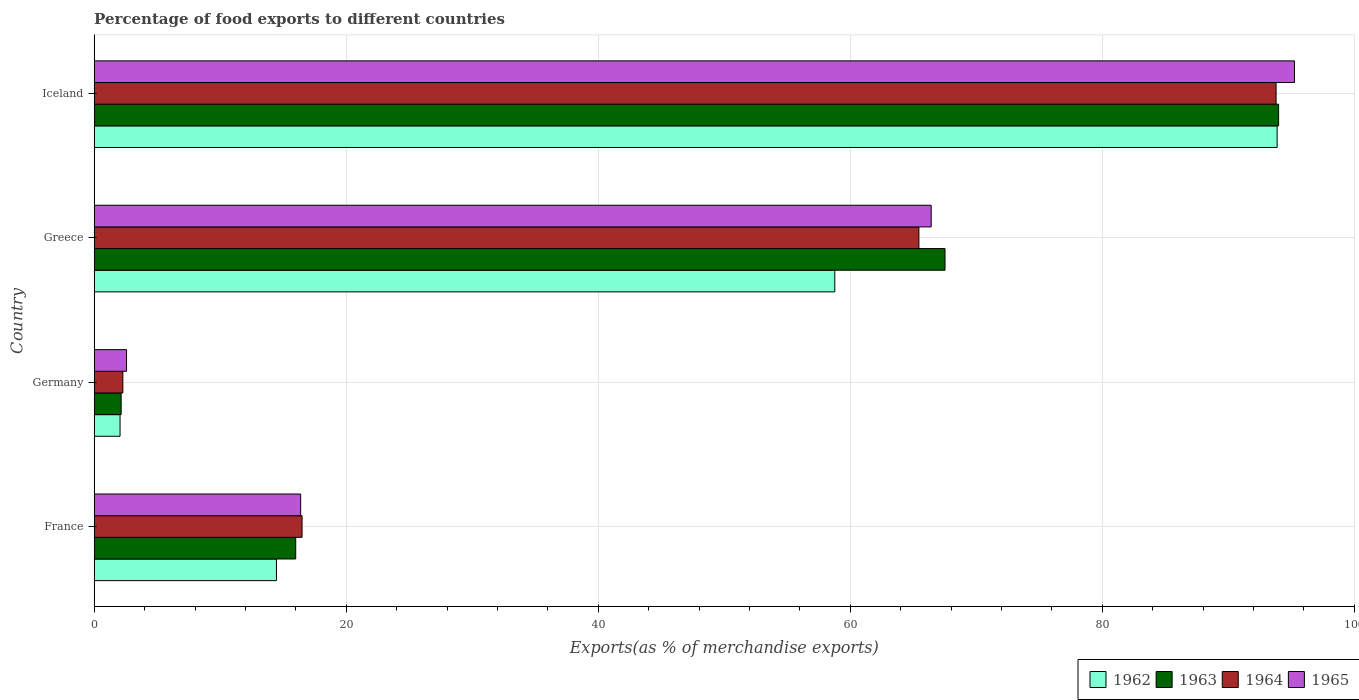How many groups of bars are there?
Your answer should be very brief. 4. Are the number of bars per tick equal to the number of legend labels?
Ensure brevity in your answer.  Yes. Are the number of bars on each tick of the Y-axis equal?
Your response must be concise. Yes. How many bars are there on the 3rd tick from the bottom?
Give a very brief answer. 4. In how many cases, is the number of bars for a given country not equal to the number of legend labels?
Your response must be concise. 0. What is the percentage of exports to different countries in 1963 in Germany?
Your answer should be compact. 2.14. Across all countries, what is the maximum percentage of exports to different countries in 1964?
Offer a terse response. 93.79. Across all countries, what is the minimum percentage of exports to different countries in 1964?
Provide a succinct answer. 2.27. In which country was the percentage of exports to different countries in 1965 maximum?
Make the answer very short. Iceland. What is the total percentage of exports to different countries in 1962 in the graph?
Your answer should be very brief. 169.16. What is the difference between the percentage of exports to different countries in 1962 in Greece and that in Iceland?
Keep it short and to the point. -35.1. What is the difference between the percentage of exports to different countries in 1964 in Greece and the percentage of exports to different countries in 1962 in Germany?
Make the answer very short. 63.39. What is the average percentage of exports to different countries in 1965 per country?
Make the answer very short. 45.16. What is the difference between the percentage of exports to different countries in 1964 and percentage of exports to different countries in 1965 in Iceland?
Provide a short and direct response. -1.46. In how many countries, is the percentage of exports to different countries in 1965 greater than 32 %?
Offer a terse response. 2. What is the ratio of the percentage of exports to different countries in 1962 in France to that in Iceland?
Provide a succinct answer. 0.15. Is the percentage of exports to different countries in 1963 in Germany less than that in Greece?
Keep it short and to the point. Yes. What is the difference between the highest and the second highest percentage of exports to different countries in 1962?
Your answer should be compact. 35.1. What is the difference between the highest and the lowest percentage of exports to different countries in 1964?
Your answer should be compact. 91.52. In how many countries, is the percentage of exports to different countries in 1963 greater than the average percentage of exports to different countries in 1963 taken over all countries?
Ensure brevity in your answer.  2. Is it the case that in every country, the sum of the percentage of exports to different countries in 1963 and percentage of exports to different countries in 1965 is greater than the sum of percentage of exports to different countries in 1962 and percentage of exports to different countries in 1964?
Your answer should be very brief. No. What does the 1st bar from the top in Greece represents?
Offer a very short reply. 1965. What does the 2nd bar from the bottom in France represents?
Give a very brief answer. 1963. Are all the bars in the graph horizontal?
Offer a terse response. Yes. How many countries are there in the graph?
Keep it short and to the point. 4. Does the graph contain grids?
Offer a terse response. Yes. How many legend labels are there?
Provide a short and direct response. 4. What is the title of the graph?
Your answer should be very brief. Percentage of food exports to different countries. What is the label or title of the X-axis?
Provide a short and direct response. Exports(as % of merchandise exports). What is the Exports(as % of merchandise exports) of 1962 in France?
Give a very brief answer. 14.46. What is the Exports(as % of merchandise exports) of 1963 in France?
Keep it short and to the point. 15.99. What is the Exports(as % of merchandise exports) in 1964 in France?
Your response must be concise. 16.5. What is the Exports(as % of merchandise exports) of 1965 in France?
Make the answer very short. 16.38. What is the Exports(as % of merchandise exports) in 1962 in Germany?
Offer a terse response. 2.05. What is the Exports(as % of merchandise exports) of 1963 in Germany?
Make the answer very short. 2.14. What is the Exports(as % of merchandise exports) of 1964 in Germany?
Make the answer very short. 2.27. What is the Exports(as % of merchandise exports) in 1965 in Germany?
Your answer should be compact. 2.57. What is the Exports(as % of merchandise exports) in 1962 in Greece?
Offer a terse response. 58.77. What is the Exports(as % of merchandise exports) in 1963 in Greece?
Give a very brief answer. 67.52. What is the Exports(as % of merchandise exports) of 1964 in Greece?
Your answer should be compact. 65.45. What is the Exports(as % of merchandise exports) in 1965 in Greece?
Your answer should be very brief. 66.42. What is the Exports(as % of merchandise exports) of 1962 in Iceland?
Keep it short and to the point. 93.87. What is the Exports(as % of merchandise exports) of 1963 in Iceland?
Give a very brief answer. 93.99. What is the Exports(as % of merchandise exports) in 1964 in Iceland?
Ensure brevity in your answer.  93.79. What is the Exports(as % of merchandise exports) of 1965 in Iceland?
Keep it short and to the point. 95.25. Across all countries, what is the maximum Exports(as % of merchandise exports) in 1962?
Give a very brief answer. 93.87. Across all countries, what is the maximum Exports(as % of merchandise exports) in 1963?
Ensure brevity in your answer.  93.99. Across all countries, what is the maximum Exports(as % of merchandise exports) in 1964?
Make the answer very short. 93.79. Across all countries, what is the maximum Exports(as % of merchandise exports) of 1965?
Provide a succinct answer. 95.25. Across all countries, what is the minimum Exports(as % of merchandise exports) in 1962?
Your response must be concise. 2.05. Across all countries, what is the minimum Exports(as % of merchandise exports) in 1963?
Offer a terse response. 2.14. Across all countries, what is the minimum Exports(as % of merchandise exports) in 1964?
Offer a very short reply. 2.27. Across all countries, what is the minimum Exports(as % of merchandise exports) of 1965?
Your answer should be very brief. 2.57. What is the total Exports(as % of merchandise exports) of 1962 in the graph?
Ensure brevity in your answer.  169.16. What is the total Exports(as % of merchandise exports) of 1963 in the graph?
Make the answer very short. 179.64. What is the total Exports(as % of merchandise exports) of 1964 in the graph?
Make the answer very short. 178.01. What is the total Exports(as % of merchandise exports) of 1965 in the graph?
Ensure brevity in your answer.  180.62. What is the difference between the Exports(as % of merchandise exports) in 1962 in France and that in Germany?
Your response must be concise. 12.41. What is the difference between the Exports(as % of merchandise exports) in 1963 in France and that in Germany?
Offer a very short reply. 13.85. What is the difference between the Exports(as % of merchandise exports) in 1964 in France and that in Germany?
Offer a very short reply. 14.22. What is the difference between the Exports(as % of merchandise exports) in 1965 in France and that in Germany?
Give a very brief answer. 13.82. What is the difference between the Exports(as % of merchandise exports) in 1962 in France and that in Greece?
Make the answer very short. -44.31. What is the difference between the Exports(as % of merchandise exports) of 1963 in France and that in Greece?
Ensure brevity in your answer.  -51.53. What is the difference between the Exports(as % of merchandise exports) in 1964 in France and that in Greece?
Make the answer very short. -48.95. What is the difference between the Exports(as % of merchandise exports) of 1965 in France and that in Greece?
Ensure brevity in your answer.  -50.04. What is the difference between the Exports(as % of merchandise exports) of 1962 in France and that in Iceland?
Make the answer very short. -79.41. What is the difference between the Exports(as % of merchandise exports) in 1963 in France and that in Iceland?
Ensure brevity in your answer.  -78. What is the difference between the Exports(as % of merchandise exports) in 1964 in France and that in Iceland?
Keep it short and to the point. -77.29. What is the difference between the Exports(as % of merchandise exports) of 1965 in France and that in Iceland?
Offer a very short reply. -78.87. What is the difference between the Exports(as % of merchandise exports) of 1962 in Germany and that in Greece?
Offer a very short reply. -56.72. What is the difference between the Exports(as % of merchandise exports) in 1963 in Germany and that in Greece?
Ensure brevity in your answer.  -65.38. What is the difference between the Exports(as % of merchandise exports) of 1964 in Germany and that in Greece?
Make the answer very short. -63.17. What is the difference between the Exports(as % of merchandise exports) of 1965 in Germany and that in Greece?
Give a very brief answer. -63.85. What is the difference between the Exports(as % of merchandise exports) of 1962 in Germany and that in Iceland?
Provide a short and direct response. -91.82. What is the difference between the Exports(as % of merchandise exports) in 1963 in Germany and that in Iceland?
Your answer should be compact. -91.85. What is the difference between the Exports(as % of merchandise exports) of 1964 in Germany and that in Iceland?
Your response must be concise. -91.52. What is the difference between the Exports(as % of merchandise exports) in 1965 in Germany and that in Iceland?
Your response must be concise. -92.68. What is the difference between the Exports(as % of merchandise exports) of 1962 in Greece and that in Iceland?
Your answer should be compact. -35.1. What is the difference between the Exports(as % of merchandise exports) of 1963 in Greece and that in Iceland?
Offer a terse response. -26.47. What is the difference between the Exports(as % of merchandise exports) of 1964 in Greece and that in Iceland?
Give a very brief answer. -28.35. What is the difference between the Exports(as % of merchandise exports) in 1965 in Greece and that in Iceland?
Your answer should be very brief. -28.83. What is the difference between the Exports(as % of merchandise exports) in 1962 in France and the Exports(as % of merchandise exports) in 1963 in Germany?
Keep it short and to the point. 12.32. What is the difference between the Exports(as % of merchandise exports) of 1962 in France and the Exports(as % of merchandise exports) of 1964 in Germany?
Your answer should be compact. 12.19. What is the difference between the Exports(as % of merchandise exports) of 1962 in France and the Exports(as % of merchandise exports) of 1965 in Germany?
Offer a very short reply. 11.9. What is the difference between the Exports(as % of merchandise exports) of 1963 in France and the Exports(as % of merchandise exports) of 1964 in Germany?
Provide a succinct answer. 13.72. What is the difference between the Exports(as % of merchandise exports) of 1963 in France and the Exports(as % of merchandise exports) of 1965 in Germany?
Provide a succinct answer. 13.42. What is the difference between the Exports(as % of merchandise exports) in 1964 in France and the Exports(as % of merchandise exports) in 1965 in Germany?
Give a very brief answer. 13.93. What is the difference between the Exports(as % of merchandise exports) in 1962 in France and the Exports(as % of merchandise exports) in 1963 in Greece?
Offer a terse response. -53.05. What is the difference between the Exports(as % of merchandise exports) of 1962 in France and the Exports(as % of merchandise exports) of 1964 in Greece?
Offer a terse response. -50.98. What is the difference between the Exports(as % of merchandise exports) in 1962 in France and the Exports(as % of merchandise exports) in 1965 in Greece?
Offer a terse response. -51.96. What is the difference between the Exports(as % of merchandise exports) of 1963 in France and the Exports(as % of merchandise exports) of 1964 in Greece?
Offer a terse response. -49.45. What is the difference between the Exports(as % of merchandise exports) of 1963 in France and the Exports(as % of merchandise exports) of 1965 in Greece?
Keep it short and to the point. -50.43. What is the difference between the Exports(as % of merchandise exports) in 1964 in France and the Exports(as % of merchandise exports) in 1965 in Greece?
Offer a very short reply. -49.93. What is the difference between the Exports(as % of merchandise exports) of 1962 in France and the Exports(as % of merchandise exports) of 1963 in Iceland?
Give a very brief answer. -79.53. What is the difference between the Exports(as % of merchandise exports) in 1962 in France and the Exports(as % of merchandise exports) in 1964 in Iceland?
Your response must be concise. -79.33. What is the difference between the Exports(as % of merchandise exports) of 1962 in France and the Exports(as % of merchandise exports) of 1965 in Iceland?
Offer a very short reply. -80.79. What is the difference between the Exports(as % of merchandise exports) in 1963 in France and the Exports(as % of merchandise exports) in 1964 in Iceland?
Provide a short and direct response. -77.8. What is the difference between the Exports(as % of merchandise exports) of 1963 in France and the Exports(as % of merchandise exports) of 1965 in Iceland?
Ensure brevity in your answer.  -79.26. What is the difference between the Exports(as % of merchandise exports) of 1964 in France and the Exports(as % of merchandise exports) of 1965 in Iceland?
Provide a succinct answer. -78.75. What is the difference between the Exports(as % of merchandise exports) of 1962 in Germany and the Exports(as % of merchandise exports) of 1963 in Greece?
Provide a succinct answer. -65.47. What is the difference between the Exports(as % of merchandise exports) in 1962 in Germany and the Exports(as % of merchandise exports) in 1964 in Greece?
Offer a very short reply. -63.39. What is the difference between the Exports(as % of merchandise exports) of 1962 in Germany and the Exports(as % of merchandise exports) of 1965 in Greece?
Your response must be concise. -64.37. What is the difference between the Exports(as % of merchandise exports) of 1963 in Germany and the Exports(as % of merchandise exports) of 1964 in Greece?
Keep it short and to the point. -63.31. What is the difference between the Exports(as % of merchandise exports) of 1963 in Germany and the Exports(as % of merchandise exports) of 1965 in Greece?
Provide a succinct answer. -64.28. What is the difference between the Exports(as % of merchandise exports) of 1964 in Germany and the Exports(as % of merchandise exports) of 1965 in Greece?
Ensure brevity in your answer.  -64.15. What is the difference between the Exports(as % of merchandise exports) of 1962 in Germany and the Exports(as % of merchandise exports) of 1963 in Iceland?
Make the answer very short. -91.94. What is the difference between the Exports(as % of merchandise exports) of 1962 in Germany and the Exports(as % of merchandise exports) of 1964 in Iceland?
Offer a terse response. -91.74. What is the difference between the Exports(as % of merchandise exports) of 1962 in Germany and the Exports(as % of merchandise exports) of 1965 in Iceland?
Your response must be concise. -93.2. What is the difference between the Exports(as % of merchandise exports) in 1963 in Germany and the Exports(as % of merchandise exports) in 1964 in Iceland?
Keep it short and to the point. -91.65. What is the difference between the Exports(as % of merchandise exports) in 1963 in Germany and the Exports(as % of merchandise exports) in 1965 in Iceland?
Ensure brevity in your answer.  -93.11. What is the difference between the Exports(as % of merchandise exports) in 1964 in Germany and the Exports(as % of merchandise exports) in 1965 in Iceland?
Make the answer very short. -92.98. What is the difference between the Exports(as % of merchandise exports) of 1962 in Greece and the Exports(as % of merchandise exports) of 1963 in Iceland?
Ensure brevity in your answer.  -35.22. What is the difference between the Exports(as % of merchandise exports) of 1962 in Greece and the Exports(as % of merchandise exports) of 1964 in Iceland?
Offer a very short reply. -35.02. What is the difference between the Exports(as % of merchandise exports) in 1962 in Greece and the Exports(as % of merchandise exports) in 1965 in Iceland?
Your answer should be compact. -36.48. What is the difference between the Exports(as % of merchandise exports) in 1963 in Greece and the Exports(as % of merchandise exports) in 1964 in Iceland?
Ensure brevity in your answer.  -26.27. What is the difference between the Exports(as % of merchandise exports) in 1963 in Greece and the Exports(as % of merchandise exports) in 1965 in Iceland?
Ensure brevity in your answer.  -27.73. What is the difference between the Exports(as % of merchandise exports) of 1964 in Greece and the Exports(as % of merchandise exports) of 1965 in Iceland?
Provide a short and direct response. -29.8. What is the average Exports(as % of merchandise exports) in 1962 per country?
Your response must be concise. 42.29. What is the average Exports(as % of merchandise exports) of 1963 per country?
Make the answer very short. 44.91. What is the average Exports(as % of merchandise exports) of 1964 per country?
Give a very brief answer. 44.5. What is the average Exports(as % of merchandise exports) of 1965 per country?
Provide a short and direct response. 45.16. What is the difference between the Exports(as % of merchandise exports) of 1962 and Exports(as % of merchandise exports) of 1963 in France?
Make the answer very short. -1.53. What is the difference between the Exports(as % of merchandise exports) of 1962 and Exports(as % of merchandise exports) of 1964 in France?
Provide a short and direct response. -2.03. What is the difference between the Exports(as % of merchandise exports) of 1962 and Exports(as % of merchandise exports) of 1965 in France?
Your answer should be very brief. -1.92. What is the difference between the Exports(as % of merchandise exports) of 1963 and Exports(as % of merchandise exports) of 1964 in France?
Provide a short and direct response. -0.5. What is the difference between the Exports(as % of merchandise exports) in 1963 and Exports(as % of merchandise exports) in 1965 in France?
Make the answer very short. -0.39. What is the difference between the Exports(as % of merchandise exports) of 1964 and Exports(as % of merchandise exports) of 1965 in France?
Ensure brevity in your answer.  0.11. What is the difference between the Exports(as % of merchandise exports) of 1962 and Exports(as % of merchandise exports) of 1963 in Germany?
Your response must be concise. -0.09. What is the difference between the Exports(as % of merchandise exports) of 1962 and Exports(as % of merchandise exports) of 1964 in Germany?
Your response must be concise. -0.22. What is the difference between the Exports(as % of merchandise exports) in 1962 and Exports(as % of merchandise exports) in 1965 in Germany?
Give a very brief answer. -0.52. What is the difference between the Exports(as % of merchandise exports) of 1963 and Exports(as % of merchandise exports) of 1964 in Germany?
Your answer should be compact. -0.14. What is the difference between the Exports(as % of merchandise exports) in 1963 and Exports(as % of merchandise exports) in 1965 in Germany?
Offer a terse response. -0.43. What is the difference between the Exports(as % of merchandise exports) of 1964 and Exports(as % of merchandise exports) of 1965 in Germany?
Make the answer very short. -0.29. What is the difference between the Exports(as % of merchandise exports) in 1962 and Exports(as % of merchandise exports) in 1963 in Greece?
Your response must be concise. -8.75. What is the difference between the Exports(as % of merchandise exports) in 1962 and Exports(as % of merchandise exports) in 1964 in Greece?
Make the answer very short. -6.67. What is the difference between the Exports(as % of merchandise exports) in 1962 and Exports(as % of merchandise exports) in 1965 in Greece?
Give a very brief answer. -7.65. What is the difference between the Exports(as % of merchandise exports) of 1963 and Exports(as % of merchandise exports) of 1964 in Greece?
Your response must be concise. 2.07. What is the difference between the Exports(as % of merchandise exports) of 1963 and Exports(as % of merchandise exports) of 1965 in Greece?
Offer a terse response. 1.1. What is the difference between the Exports(as % of merchandise exports) of 1964 and Exports(as % of merchandise exports) of 1965 in Greece?
Give a very brief answer. -0.98. What is the difference between the Exports(as % of merchandise exports) in 1962 and Exports(as % of merchandise exports) in 1963 in Iceland?
Your response must be concise. -0.12. What is the difference between the Exports(as % of merchandise exports) in 1962 and Exports(as % of merchandise exports) in 1964 in Iceland?
Provide a succinct answer. 0.08. What is the difference between the Exports(as % of merchandise exports) of 1962 and Exports(as % of merchandise exports) of 1965 in Iceland?
Make the answer very short. -1.38. What is the difference between the Exports(as % of merchandise exports) of 1963 and Exports(as % of merchandise exports) of 1964 in Iceland?
Ensure brevity in your answer.  0.2. What is the difference between the Exports(as % of merchandise exports) of 1963 and Exports(as % of merchandise exports) of 1965 in Iceland?
Your answer should be very brief. -1.26. What is the difference between the Exports(as % of merchandise exports) in 1964 and Exports(as % of merchandise exports) in 1965 in Iceland?
Your answer should be compact. -1.46. What is the ratio of the Exports(as % of merchandise exports) in 1962 in France to that in Germany?
Give a very brief answer. 7.05. What is the ratio of the Exports(as % of merchandise exports) in 1963 in France to that in Germany?
Provide a short and direct response. 7.48. What is the ratio of the Exports(as % of merchandise exports) of 1964 in France to that in Germany?
Make the answer very short. 7.25. What is the ratio of the Exports(as % of merchandise exports) of 1965 in France to that in Germany?
Offer a terse response. 6.38. What is the ratio of the Exports(as % of merchandise exports) in 1962 in France to that in Greece?
Keep it short and to the point. 0.25. What is the ratio of the Exports(as % of merchandise exports) in 1963 in France to that in Greece?
Your answer should be very brief. 0.24. What is the ratio of the Exports(as % of merchandise exports) of 1964 in France to that in Greece?
Your answer should be compact. 0.25. What is the ratio of the Exports(as % of merchandise exports) in 1965 in France to that in Greece?
Provide a short and direct response. 0.25. What is the ratio of the Exports(as % of merchandise exports) of 1962 in France to that in Iceland?
Your response must be concise. 0.15. What is the ratio of the Exports(as % of merchandise exports) in 1963 in France to that in Iceland?
Keep it short and to the point. 0.17. What is the ratio of the Exports(as % of merchandise exports) of 1964 in France to that in Iceland?
Provide a short and direct response. 0.18. What is the ratio of the Exports(as % of merchandise exports) of 1965 in France to that in Iceland?
Your response must be concise. 0.17. What is the ratio of the Exports(as % of merchandise exports) in 1962 in Germany to that in Greece?
Your answer should be very brief. 0.03. What is the ratio of the Exports(as % of merchandise exports) in 1963 in Germany to that in Greece?
Offer a very short reply. 0.03. What is the ratio of the Exports(as % of merchandise exports) of 1964 in Germany to that in Greece?
Provide a short and direct response. 0.03. What is the ratio of the Exports(as % of merchandise exports) in 1965 in Germany to that in Greece?
Your response must be concise. 0.04. What is the ratio of the Exports(as % of merchandise exports) in 1962 in Germany to that in Iceland?
Provide a short and direct response. 0.02. What is the ratio of the Exports(as % of merchandise exports) of 1963 in Germany to that in Iceland?
Your answer should be very brief. 0.02. What is the ratio of the Exports(as % of merchandise exports) in 1964 in Germany to that in Iceland?
Provide a succinct answer. 0.02. What is the ratio of the Exports(as % of merchandise exports) in 1965 in Germany to that in Iceland?
Offer a terse response. 0.03. What is the ratio of the Exports(as % of merchandise exports) of 1962 in Greece to that in Iceland?
Offer a very short reply. 0.63. What is the ratio of the Exports(as % of merchandise exports) in 1963 in Greece to that in Iceland?
Your answer should be very brief. 0.72. What is the ratio of the Exports(as % of merchandise exports) in 1964 in Greece to that in Iceland?
Make the answer very short. 0.7. What is the ratio of the Exports(as % of merchandise exports) of 1965 in Greece to that in Iceland?
Provide a short and direct response. 0.7. What is the difference between the highest and the second highest Exports(as % of merchandise exports) in 1962?
Provide a succinct answer. 35.1. What is the difference between the highest and the second highest Exports(as % of merchandise exports) of 1963?
Provide a short and direct response. 26.47. What is the difference between the highest and the second highest Exports(as % of merchandise exports) in 1964?
Your response must be concise. 28.35. What is the difference between the highest and the second highest Exports(as % of merchandise exports) of 1965?
Your response must be concise. 28.83. What is the difference between the highest and the lowest Exports(as % of merchandise exports) of 1962?
Keep it short and to the point. 91.82. What is the difference between the highest and the lowest Exports(as % of merchandise exports) of 1963?
Offer a very short reply. 91.85. What is the difference between the highest and the lowest Exports(as % of merchandise exports) of 1964?
Your answer should be compact. 91.52. What is the difference between the highest and the lowest Exports(as % of merchandise exports) of 1965?
Your answer should be very brief. 92.68. 